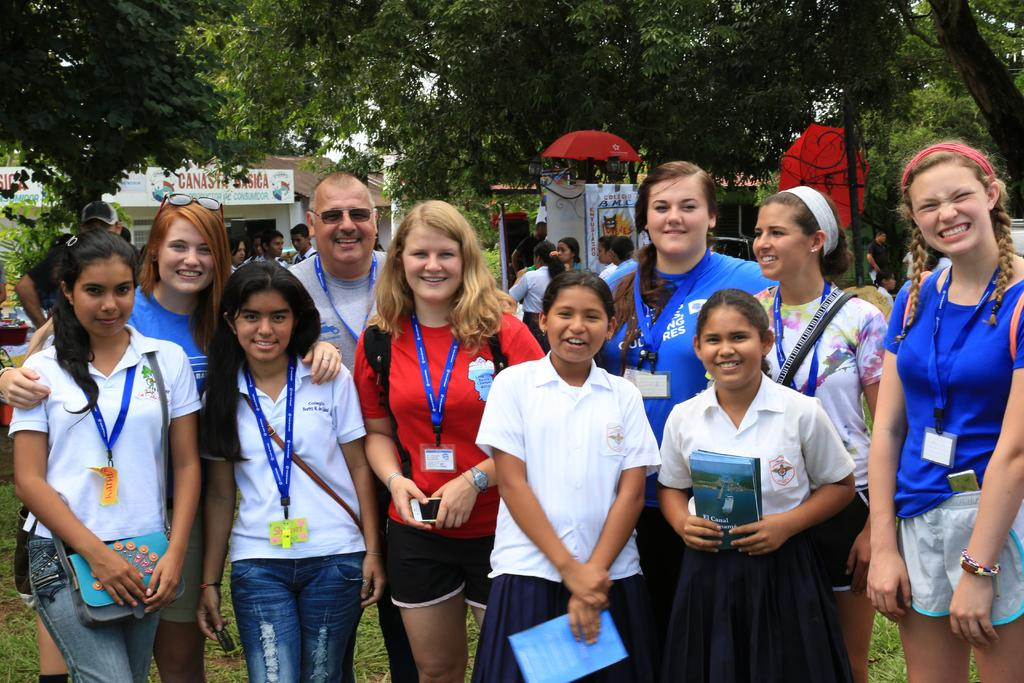What are the people in the image doing? There is a group of persons standing on the ground in the image. What can be seen in the background of the image? There is an umbrella, at least one building, persons, trees, and the sky visible in the background of the image. What invention is being demonstrated by the persons in the image? There is no invention being demonstrated in the image; the persons are simply standing on the ground. What is the place where the persons are standing in the image? The location of the image is not specified, so it is not possible to determine the place where the persons are standing. 